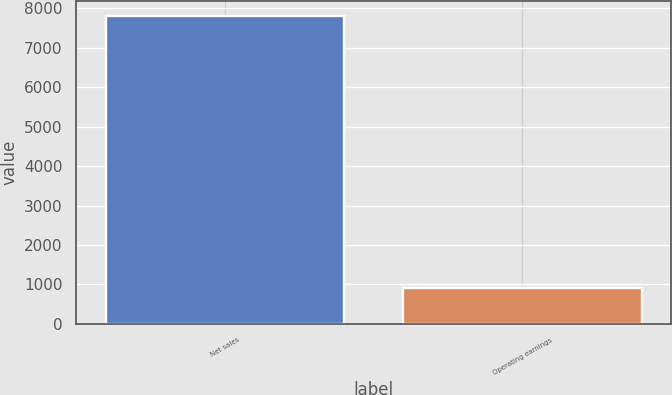<chart> <loc_0><loc_0><loc_500><loc_500><bar_chart><fcel>Net sales<fcel>Operating earnings<nl><fcel>7797<fcel>916<nl></chart> 